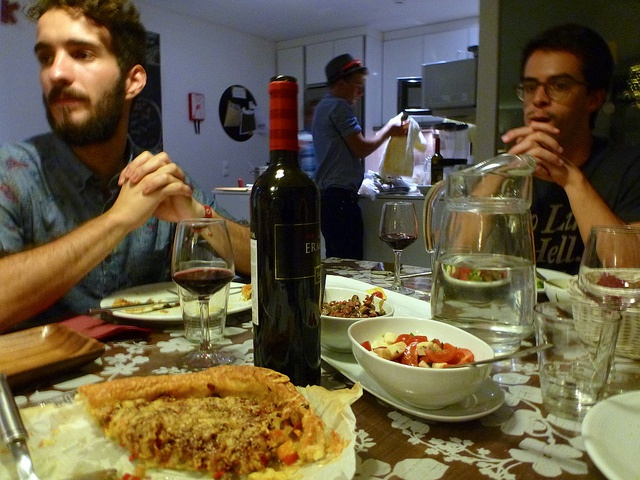Describe the objects in this image and their specific colors. I can see dining table in gray, black, and olive tones, people in gray, black, maroon, olive, and tan tones, people in gray, black, olive, and maroon tones, bottle in gray, black, maroon, and darkgreen tones, and bowl in gray, olive, and beige tones in this image. 